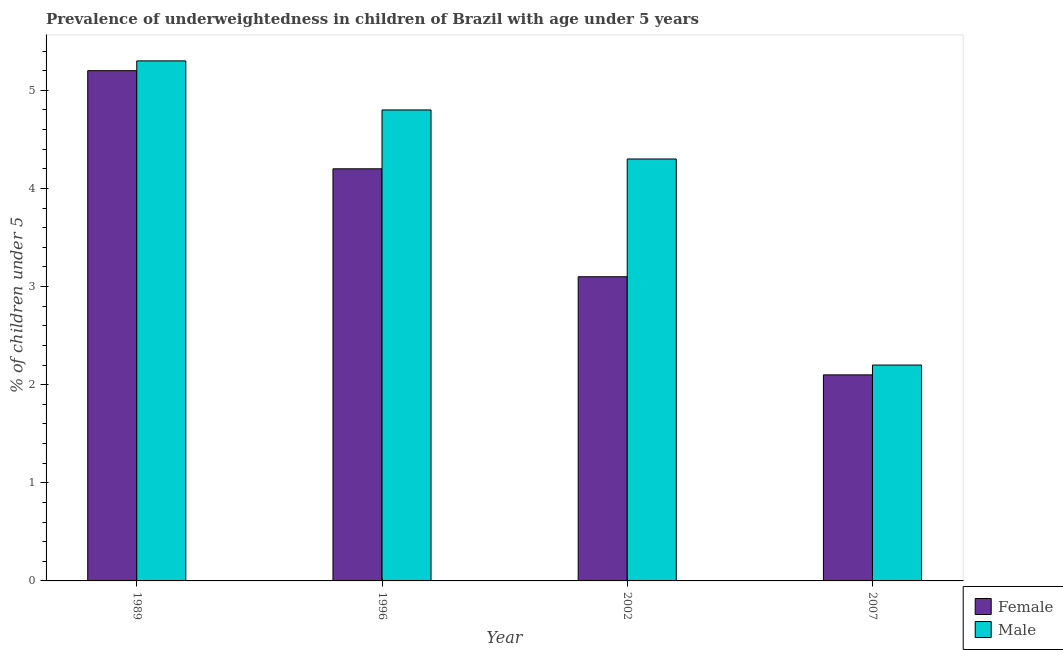Are the number of bars per tick equal to the number of legend labels?
Your answer should be compact. Yes. Are the number of bars on each tick of the X-axis equal?
Offer a very short reply. Yes. How many bars are there on the 1st tick from the left?
Give a very brief answer. 2. How many bars are there on the 2nd tick from the right?
Provide a succinct answer. 2. What is the percentage of underweighted male children in 1996?
Provide a short and direct response. 4.8. Across all years, what is the maximum percentage of underweighted male children?
Ensure brevity in your answer.  5.3. Across all years, what is the minimum percentage of underweighted female children?
Your answer should be compact. 2.1. In which year was the percentage of underweighted male children maximum?
Make the answer very short. 1989. What is the total percentage of underweighted female children in the graph?
Ensure brevity in your answer.  14.6. What is the difference between the percentage of underweighted male children in 1989 and the percentage of underweighted female children in 2002?
Offer a very short reply. 1. What is the average percentage of underweighted female children per year?
Offer a very short reply. 3.65. In the year 2002, what is the difference between the percentage of underweighted female children and percentage of underweighted male children?
Keep it short and to the point. 0. Is the percentage of underweighted female children in 1996 less than that in 2007?
Keep it short and to the point. No. Is the difference between the percentage of underweighted female children in 1996 and 2002 greater than the difference between the percentage of underweighted male children in 1996 and 2002?
Offer a very short reply. No. What is the difference between the highest and the second highest percentage of underweighted male children?
Your answer should be compact. 0.5. What is the difference between the highest and the lowest percentage of underweighted male children?
Provide a succinct answer. 3.1. What does the 2nd bar from the left in 1996 represents?
Your answer should be very brief. Male. How many bars are there?
Offer a terse response. 8. How many years are there in the graph?
Keep it short and to the point. 4. What is the difference between two consecutive major ticks on the Y-axis?
Offer a very short reply. 1. Does the graph contain any zero values?
Your response must be concise. No. Does the graph contain grids?
Provide a short and direct response. No. Where does the legend appear in the graph?
Make the answer very short. Bottom right. How many legend labels are there?
Ensure brevity in your answer.  2. What is the title of the graph?
Give a very brief answer. Prevalence of underweightedness in children of Brazil with age under 5 years. What is the label or title of the X-axis?
Give a very brief answer. Year. What is the label or title of the Y-axis?
Keep it short and to the point.  % of children under 5. What is the  % of children under 5 in Female in 1989?
Your answer should be compact. 5.2. What is the  % of children under 5 in Male in 1989?
Ensure brevity in your answer.  5.3. What is the  % of children under 5 in Female in 1996?
Make the answer very short. 4.2. What is the  % of children under 5 in Male in 1996?
Keep it short and to the point. 4.8. What is the  % of children under 5 of Female in 2002?
Ensure brevity in your answer.  3.1. What is the  % of children under 5 of Male in 2002?
Offer a terse response. 4.3. What is the  % of children under 5 of Female in 2007?
Your answer should be compact. 2.1. What is the  % of children under 5 in Male in 2007?
Provide a succinct answer. 2.2. Across all years, what is the maximum  % of children under 5 of Female?
Make the answer very short. 5.2. Across all years, what is the maximum  % of children under 5 of Male?
Provide a succinct answer. 5.3. Across all years, what is the minimum  % of children under 5 in Female?
Your response must be concise. 2.1. Across all years, what is the minimum  % of children under 5 in Male?
Make the answer very short. 2.2. What is the total  % of children under 5 of Female in the graph?
Your answer should be compact. 14.6. What is the difference between the  % of children under 5 in Female in 1989 and that in 1996?
Give a very brief answer. 1. What is the difference between the  % of children under 5 in Female in 1989 and that in 2007?
Keep it short and to the point. 3.1. What is the difference between the  % of children under 5 of Male in 1996 and that in 2002?
Ensure brevity in your answer.  0.5. What is the difference between the  % of children under 5 in Male in 1996 and that in 2007?
Keep it short and to the point. 2.6. What is the difference between the  % of children under 5 of Male in 2002 and that in 2007?
Provide a short and direct response. 2.1. What is the difference between the  % of children under 5 of Female in 1989 and the  % of children under 5 of Male in 1996?
Provide a succinct answer. 0.4. What is the difference between the  % of children under 5 in Female in 1989 and the  % of children under 5 in Male in 2002?
Your answer should be very brief. 0.9. What is the difference between the  % of children under 5 in Female in 1996 and the  % of children under 5 in Male in 2007?
Ensure brevity in your answer.  2. What is the average  % of children under 5 in Female per year?
Keep it short and to the point. 3.65. What is the average  % of children under 5 of Male per year?
Keep it short and to the point. 4.15. In the year 1989, what is the difference between the  % of children under 5 in Female and  % of children under 5 in Male?
Provide a succinct answer. -0.1. In the year 2007, what is the difference between the  % of children under 5 of Female and  % of children under 5 of Male?
Offer a terse response. -0.1. What is the ratio of the  % of children under 5 in Female in 1989 to that in 1996?
Your response must be concise. 1.24. What is the ratio of the  % of children under 5 in Male in 1989 to that in 1996?
Keep it short and to the point. 1.1. What is the ratio of the  % of children under 5 of Female in 1989 to that in 2002?
Your answer should be compact. 1.68. What is the ratio of the  % of children under 5 of Male in 1989 to that in 2002?
Your answer should be very brief. 1.23. What is the ratio of the  % of children under 5 in Female in 1989 to that in 2007?
Your response must be concise. 2.48. What is the ratio of the  % of children under 5 in Male in 1989 to that in 2007?
Ensure brevity in your answer.  2.41. What is the ratio of the  % of children under 5 of Female in 1996 to that in 2002?
Make the answer very short. 1.35. What is the ratio of the  % of children under 5 in Male in 1996 to that in 2002?
Offer a very short reply. 1.12. What is the ratio of the  % of children under 5 of Female in 1996 to that in 2007?
Offer a very short reply. 2. What is the ratio of the  % of children under 5 of Male in 1996 to that in 2007?
Offer a very short reply. 2.18. What is the ratio of the  % of children under 5 of Female in 2002 to that in 2007?
Give a very brief answer. 1.48. What is the ratio of the  % of children under 5 of Male in 2002 to that in 2007?
Your response must be concise. 1.95. What is the difference between the highest and the second highest  % of children under 5 in Female?
Your response must be concise. 1. 